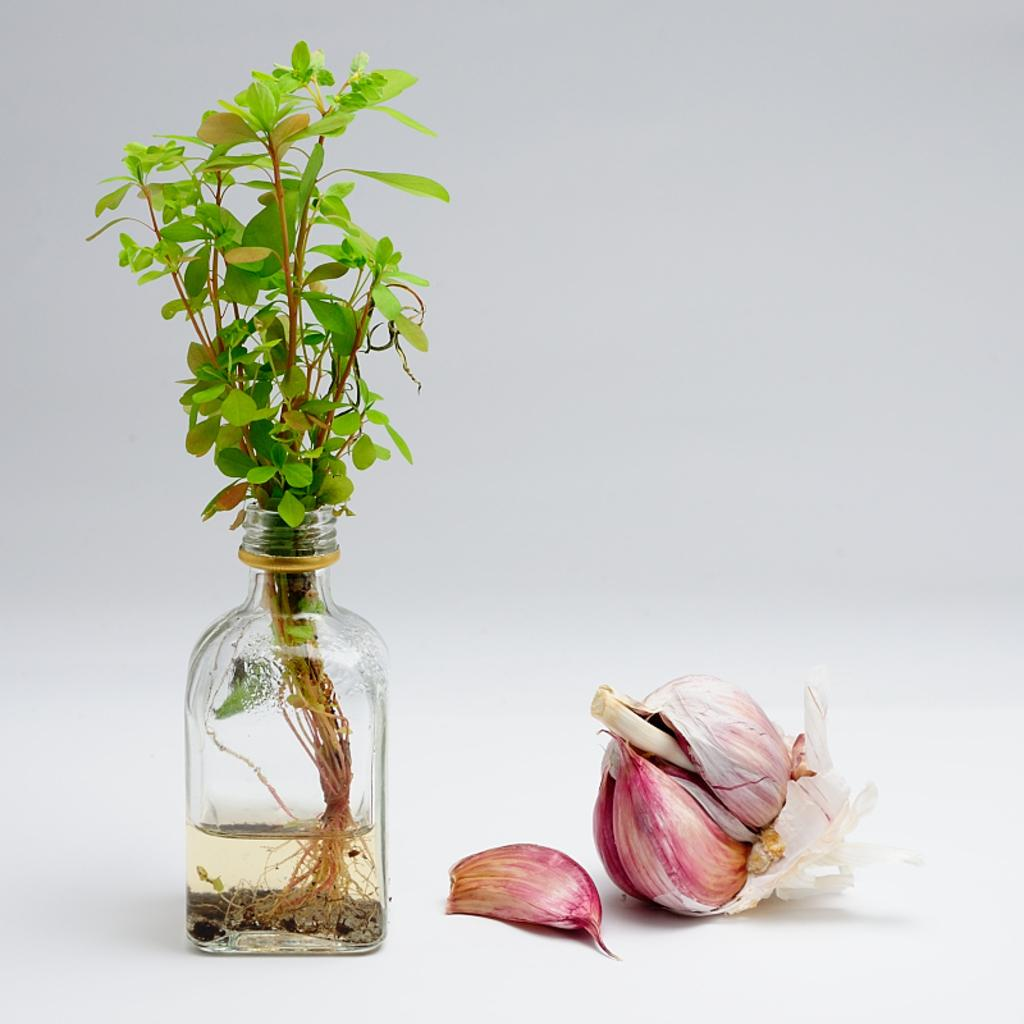What is the main object in the image? There is an onion in the image. What other object can be seen in the image? There is a bottle in the image. What is inside the bottle? The bottle contains a plant. What type of leather material can be seen in the image? There is no leather material present in the image. What type of badge is visible on the onion in the image? There is no badge present on the onion in the image. 